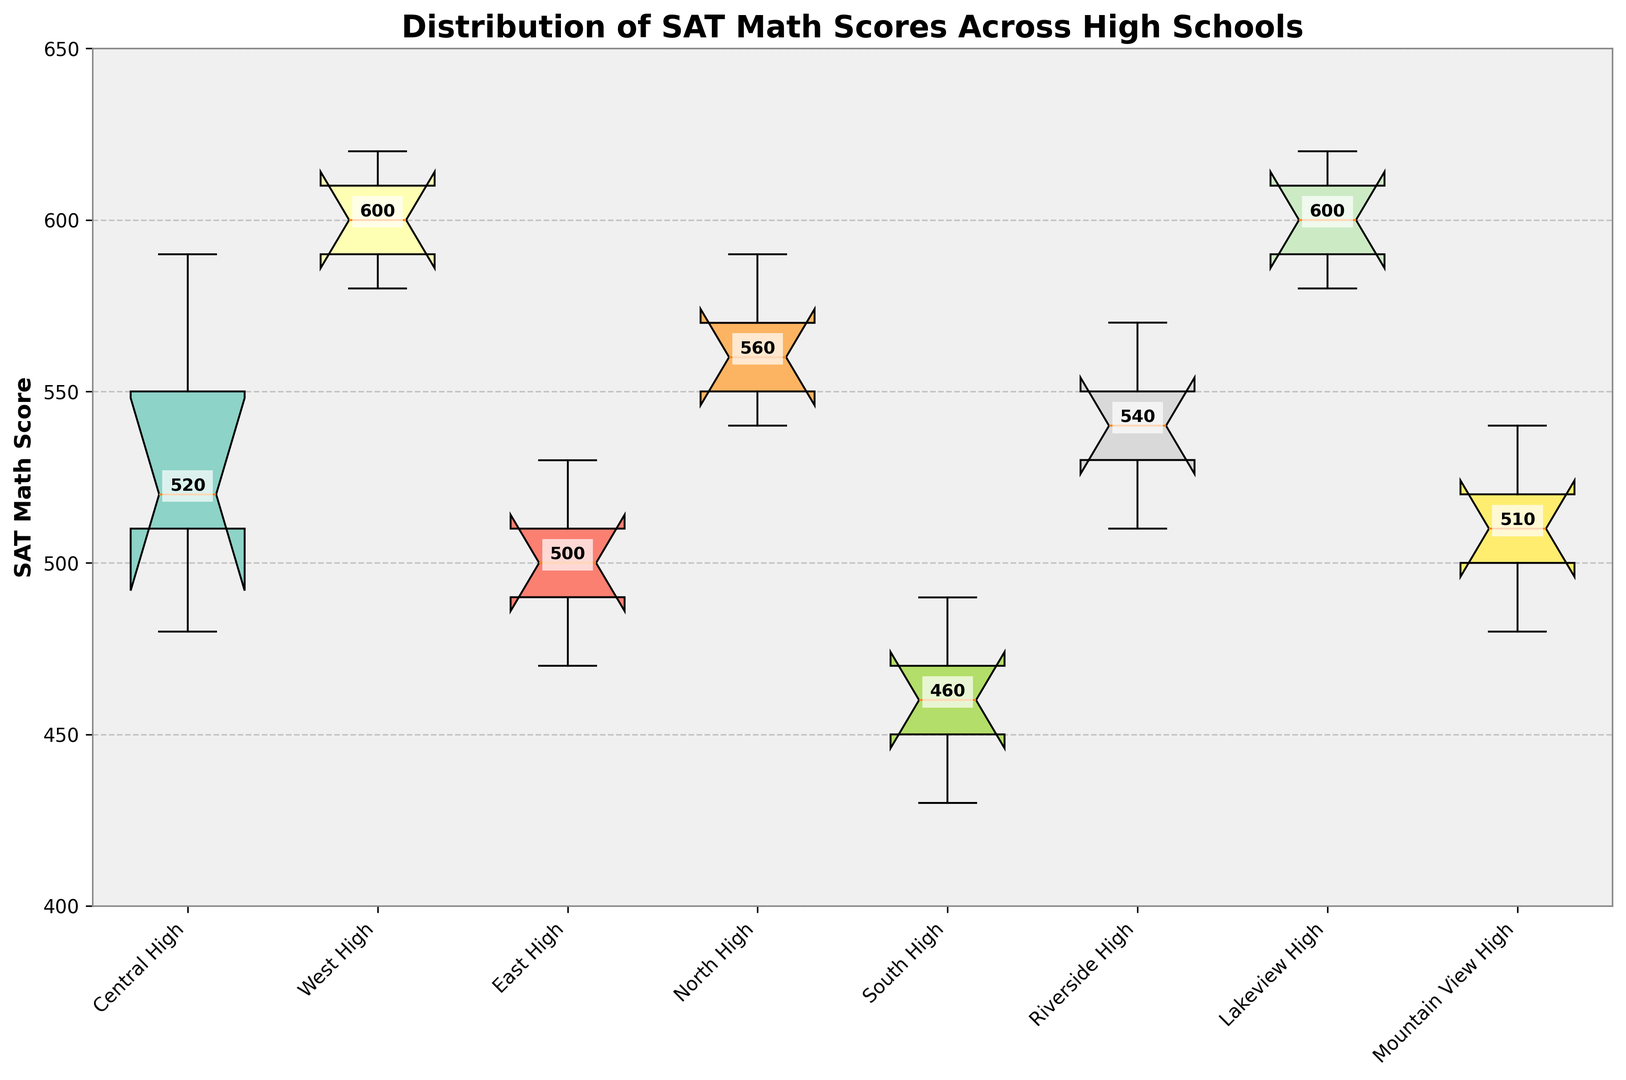What is the median SAT Math score of Central High? The box plot shows the median value marked inside the box with a horizontal line. For Central High, the median SAT Math score is labeled on the plot.
Answer: 520 Which school has the highest median SAT Math score? The box plot displays the median score for each school. The school with the highest labeled median value should be selected.
Answer: Lakeview High and West High What is the range of SAT Math scores for South High? The range of a data set is the difference between the highest and lowest values. In the box plot, locate the upper and lower whiskers of the box for South High and calculate the difference between these values.
Answer: 40 Which school has the smallest interquartile range (IQR)? The IQR is the range between the first quartile (Q1) and the third quartile (Q3). In the box plot, find the school with the narrowest box, which represents the smallest IQR.
Answer: Mountain View High Are there any schools with outliers in their SAT Math scores? Outliers are typically shown as individual points beyond the whiskers of the box plot. Identify any such points for each school in the figure.
Answer: No Based on the box plot, which school has the lowest minimum SAT Math score? Locate the school with the lowest point on the lower whisker in the box plot.
Answer: South High What is the difference between the median SAT Math scores of East High and North High? Subtract the median SAT Math score of East High from that of North High by observing the labeled medians for both schools in the plot.
Answer: 50 Which two schools have a similar distribution based on their box plots? Identify two schools whose box plots have similar shapes and spread, indicating a similar distribution of SAT Math scores.
Answer: North High and Riverside High What is the upper quartile (Q3) SAT Math score for Lakeview High? The upper quartile (Q3) is marked by the top line of the box in a box plot. Locate this value for Lakeview High.
Answer: 620 